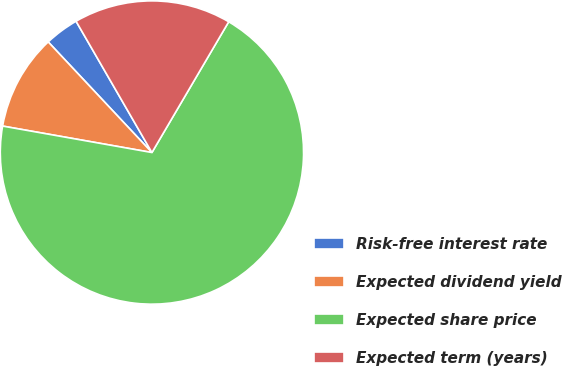<chart> <loc_0><loc_0><loc_500><loc_500><pie_chart><fcel>Risk-free interest rate<fcel>Expected dividend yield<fcel>Expected share price<fcel>Expected term (years)<nl><fcel>3.65%<fcel>10.22%<fcel>69.34%<fcel>16.79%<nl></chart> 